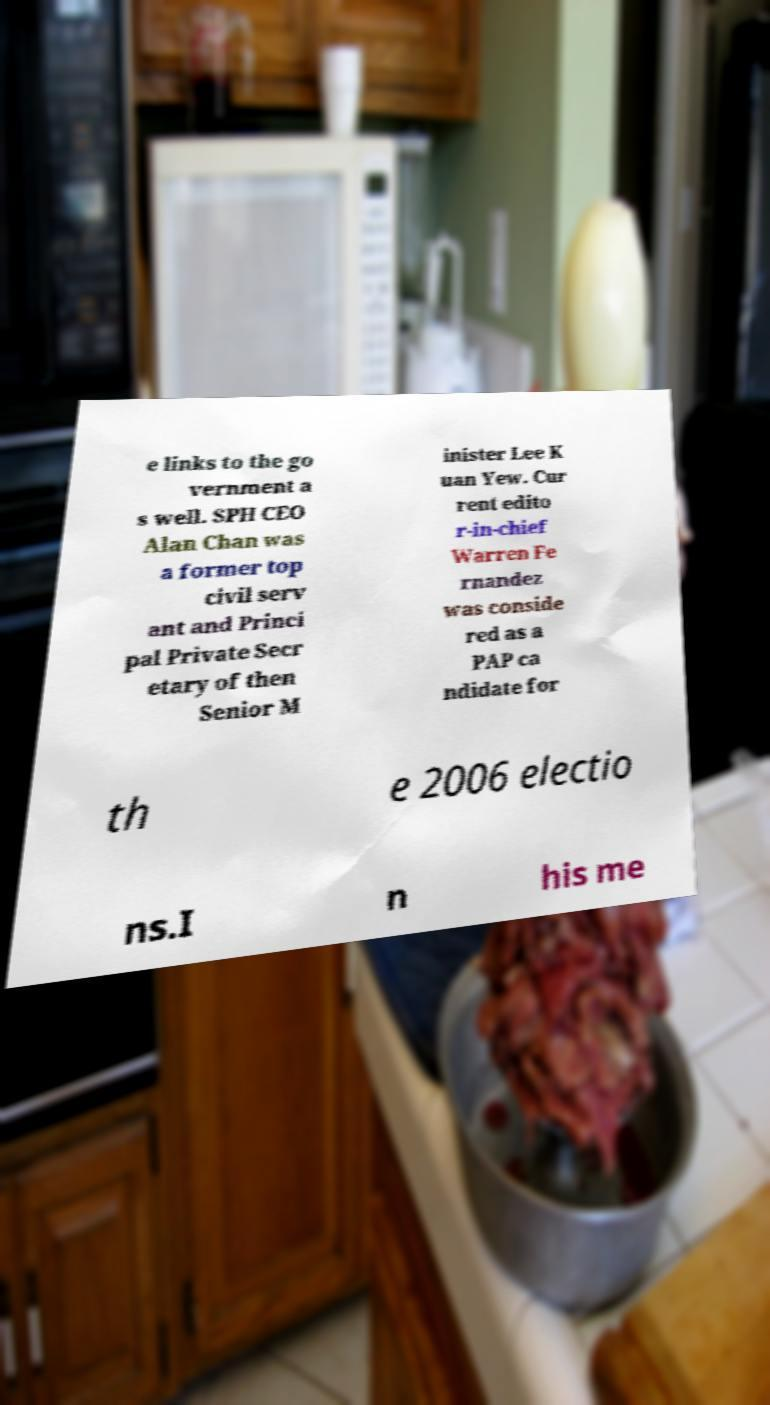There's text embedded in this image that I need extracted. Can you transcribe it verbatim? e links to the go vernment a s well. SPH CEO Alan Chan was a former top civil serv ant and Princi pal Private Secr etary of then Senior M inister Lee K uan Yew. Cur rent edito r-in-chief Warren Fe rnandez was conside red as a PAP ca ndidate for th e 2006 electio ns.I n his me 